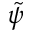Convert formula to latex. <formula><loc_0><loc_0><loc_500><loc_500>\tilde { \psi }</formula> 